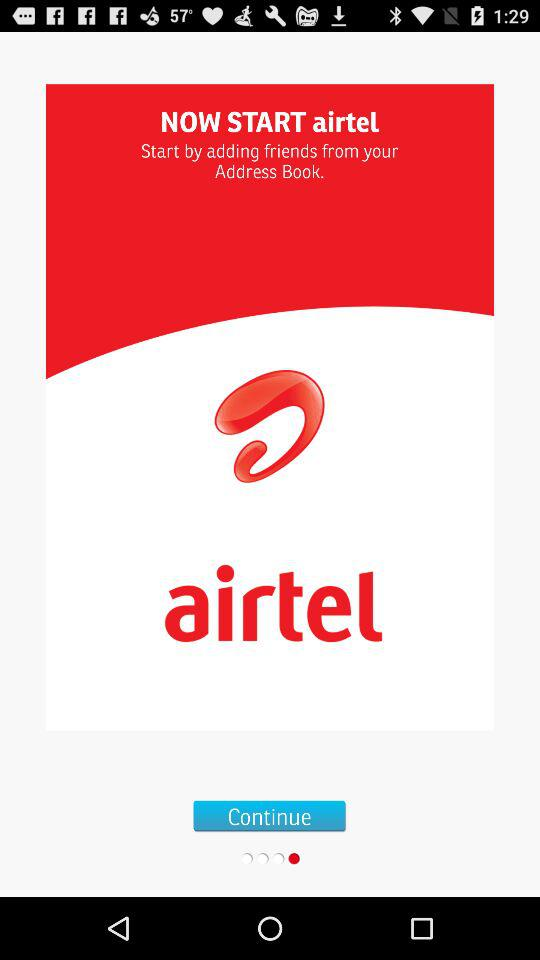Which friends were added to the address book?
When the provided information is insufficient, respond with <no answer>. <no answer> 